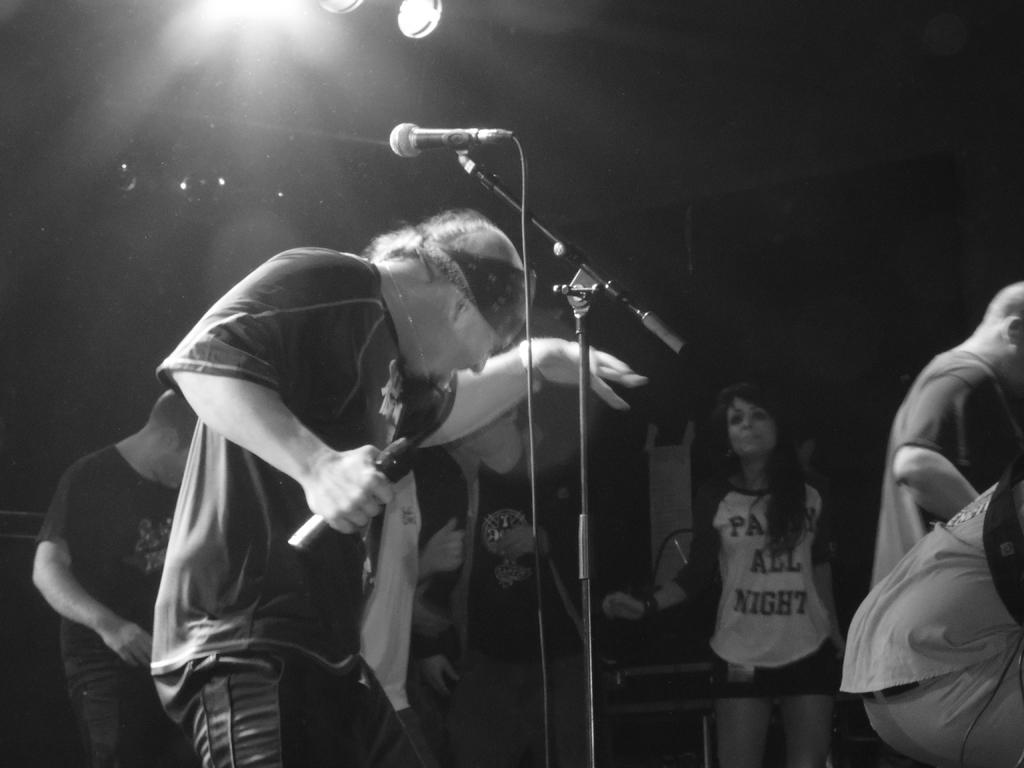Who is the main subject in the image? There is a person in the image. What is the person holding in the image? The person is holding a microphone. Can you describe the surrounding environment in the image? There are people around the person in the image. Is there another microphone visible in the image? Yes, there is a microphone in front of the person. What time of day is it in the image, given the presence of a morning rainstorm? There is no mention of a rainstorm or morning in the image, so we cannot determine the time of day based on that information. 